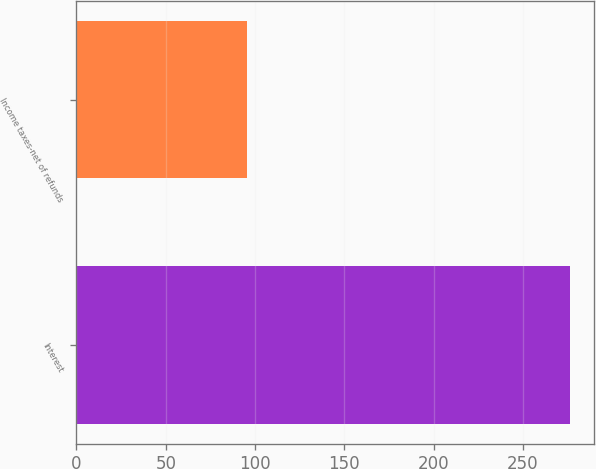Convert chart to OTSL. <chart><loc_0><loc_0><loc_500><loc_500><bar_chart><fcel>Interest<fcel>Income taxes-net of refunds<nl><fcel>276.2<fcel>95.5<nl></chart> 